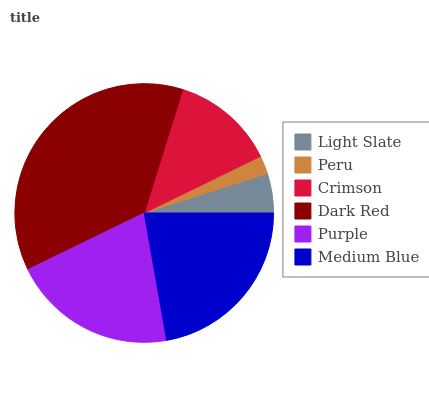Is Peru the minimum?
Answer yes or no. Yes. Is Dark Red the maximum?
Answer yes or no. Yes. Is Crimson the minimum?
Answer yes or no. No. Is Crimson the maximum?
Answer yes or no. No. Is Crimson greater than Peru?
Answer yes or no. Yes. Is Peru less than Crimson?
Answer yes or no. Yes. Is Peru greater than Crimson?
Answer yes or no. No. Is Crimson less than Peru?
Answer yes or no. No. Is Purple the high median?
Answer yes or no. Yes. Is Crimson the low median?
Answer yes or no. Yes. Is Dark Red the high median?
Answer yes or no. No. Is Medium Blue the low median?
Answer yes or no. No. 